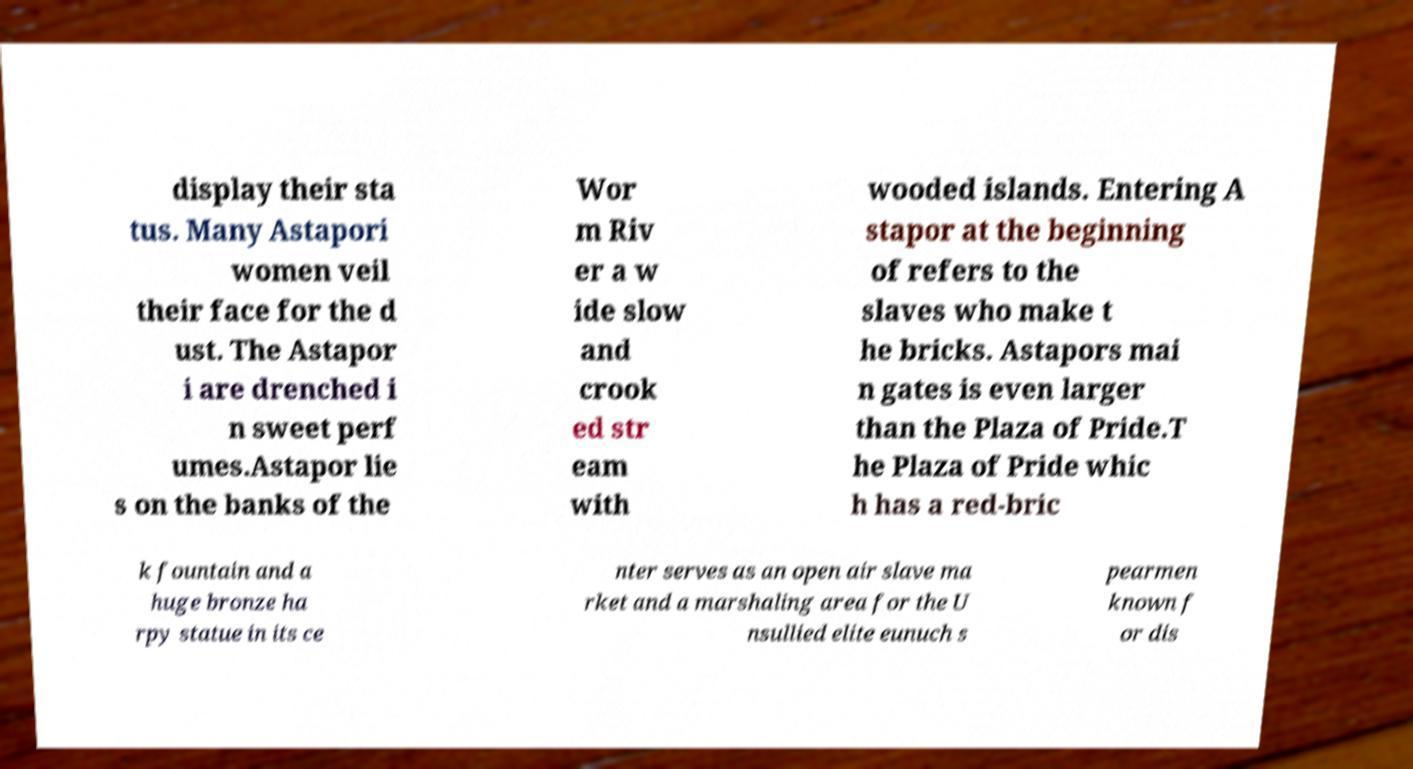Please identify and transcribe the text found in this image. display their sta tus. Many Astapori women veil their face for the d ust. The Astapor i are drenched i n sweet perf umes.Astapor lie s on the banks of the Wor m Riv er a w ide slow and crook ed str eam with wooded islands. Entering A stapor at the beginning of refers to the slaves who make t he bricks. Astapors mai n gates is even larger than the Plaza of Pride.T he Plaza of Pride whic h has a red-bric k fountain and a huge bronze ha rpy statue in its ce nter serves as an open air slave ma rket and a marshaling area for the U nsullied elite eunuch s pearmen known f or dis 